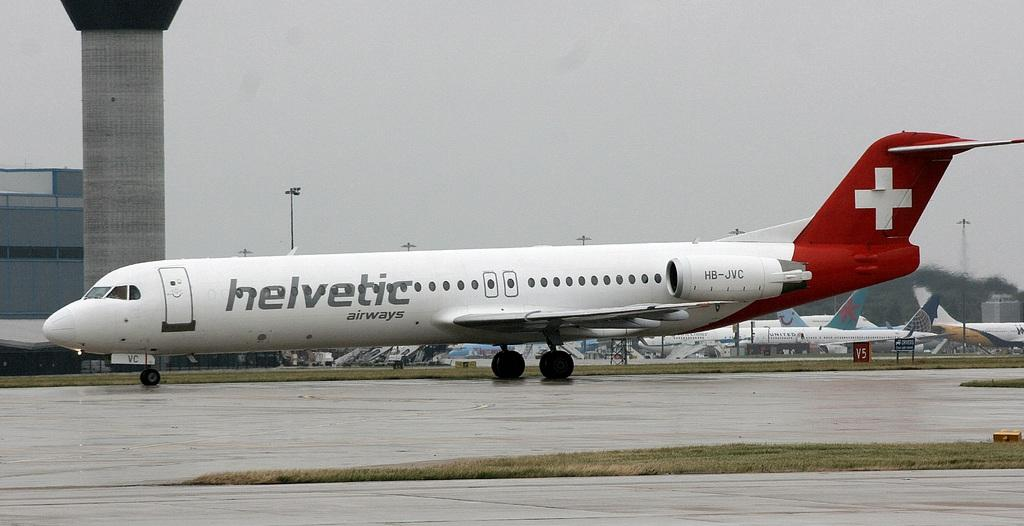Provide a one-sentence caption for the provided image. a helvetic airplane with a red cross symbol on the tail. 